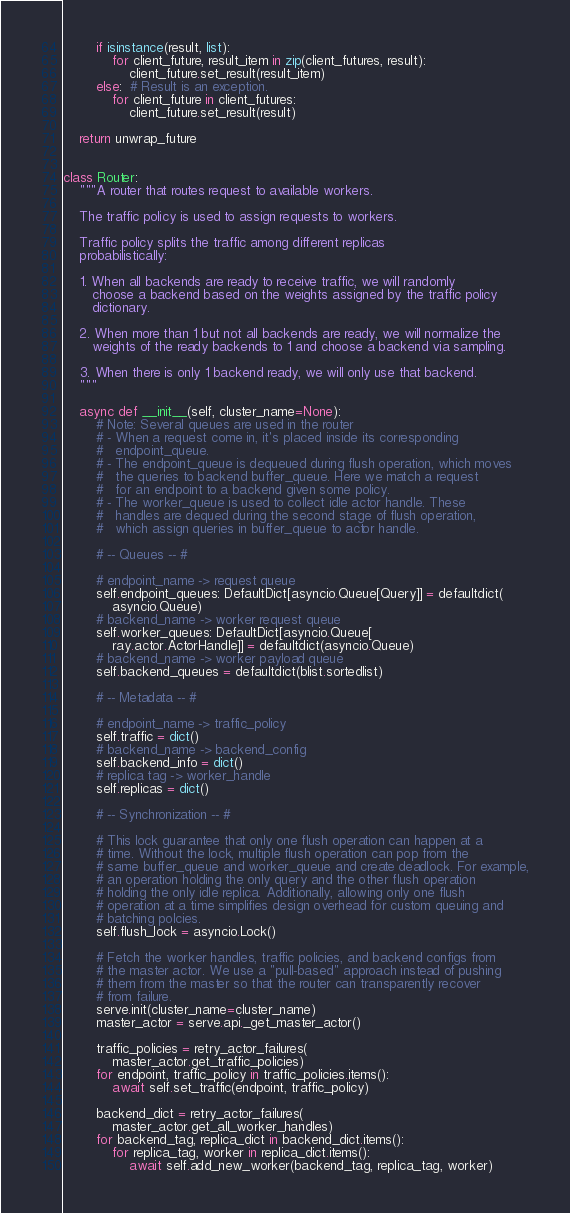Convert code to text. <code><loc_0><loc_0><loc_500><loc_500><_Python_>        if isinstance(result, list):
            for client_future, result_item in zip(client_futures, result):
                client_future.set_result(result_item)
        else:  # Result is an exception.
            for client_future in client_futures:
                client_future.set_result(result)

    return unwrap_future


class Router:
    """A router that routes request to available workers.

    The traffic policy is used to assign requests to workers.

    Traffic policy splits the traffic among different replicas
    probabilistically:

    1. When all backends are ready to receive traffic, we will randomly
       choose a backend based on the weights assigned by the traffic policy
       dictionary.

    2. When more than 1 but not all backends are ready, we will normalize the
       weights of the ready backends to 1 and choose a backend via sampling.

    3. When there is only 1 backend ready, we will only use that backend.
    """

    async def __init__(self, cluster_name=None):
        # Note: Several queues are used in the router
        # - When a request come in, it's placed inside its corresponding
        #   endpoint_queue.
        # - The endpoint_queue is dequeued during flush operation, which moves
        #   the queries to backend buffer_queue. Here we match a request
        #   for an endpoint to a backend given some policy.
        # - The worker_queue is used to collect idle actor handle. These
        #   handles are dequed during the second stage of flush operation,
        #   which assign queries in buffer_queue to actor handle.

        # -- Queues -- #

        # endpoint_name -> request queue
        self.endpoint_queues: DefaultDict[asyncio.Queue[Query]] = defaultdict(
            asyncio.Queue)
        # backend_name -> worker request queue
        self.worker_queues: DefaultDict[asyncio.Queue[
            ray.actor.ActorHandle]] = defaultdict(asyncio.Queue)
        # backend_name -> worker payload queue
        self.backend_queues = defaultdict(blist.sortedlist)

        # -- Metadata -- #

        # endpoint_name -> traffic_policy
        self.traffic = dict()
        # backend_name -> backend_config
        self.backend_info = dict()
        # replica tag -> worker_handle
        self.replicas = dict()

        # -- Synchronization -- #

        # This lock guarantee that only one flush operation can happen at a
        # time. Without the lock, multiple flush operation can pop from the
        # same buffer_queue and worker_queue and create deadlock. For example,
        # an operation holding the only query and the other flush operation
        # holding the only idle replica. Additionally, allowing only one flush
        # operation at a time simplifies design overhead for custom queuing and
        # batching polcies.
        self.flush_lock = asyncio.Lock()

        # Fetch the worker handles, traffic policies, and backend configs from
        # the master actor. We use a "pull-based" approach instead of pushing
        # them from the master so that the router can transparently recover
        # from failure.
        serve.init(cluster_name=cluster_name)
        master_actor = serve.api._get_master_actor()

        traffic_policies = retry_actor_failures(
            master_actor.get_traffic_policies)
        for endpoint, traffic_policy in traffic_policies.items():
            await self.set_traffic(endpoint, traffic_policy)

        backend_dict = retry_actor_failures(
            master_actor.get_all_worker_handles)
        for backend_tag, replica_dict in backend_dict.items():
            for replica_tag, worker in replica_dict.items():
                await self.add_new_worker(backend_tag, replica_tag, worker)
</code> 